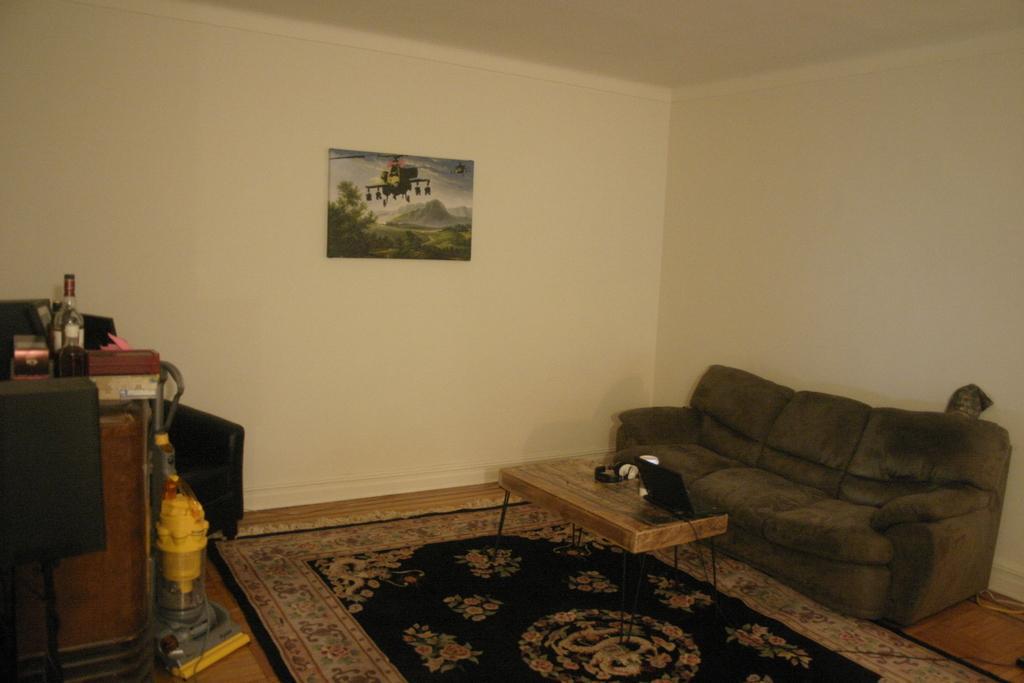How would you summarize this image in a sentence or two? This is the picture of a room where we have a sofa and a table to the left side and a desk on which some things are placed to the right side and there is a frame to the wall and door mat on the floor. 